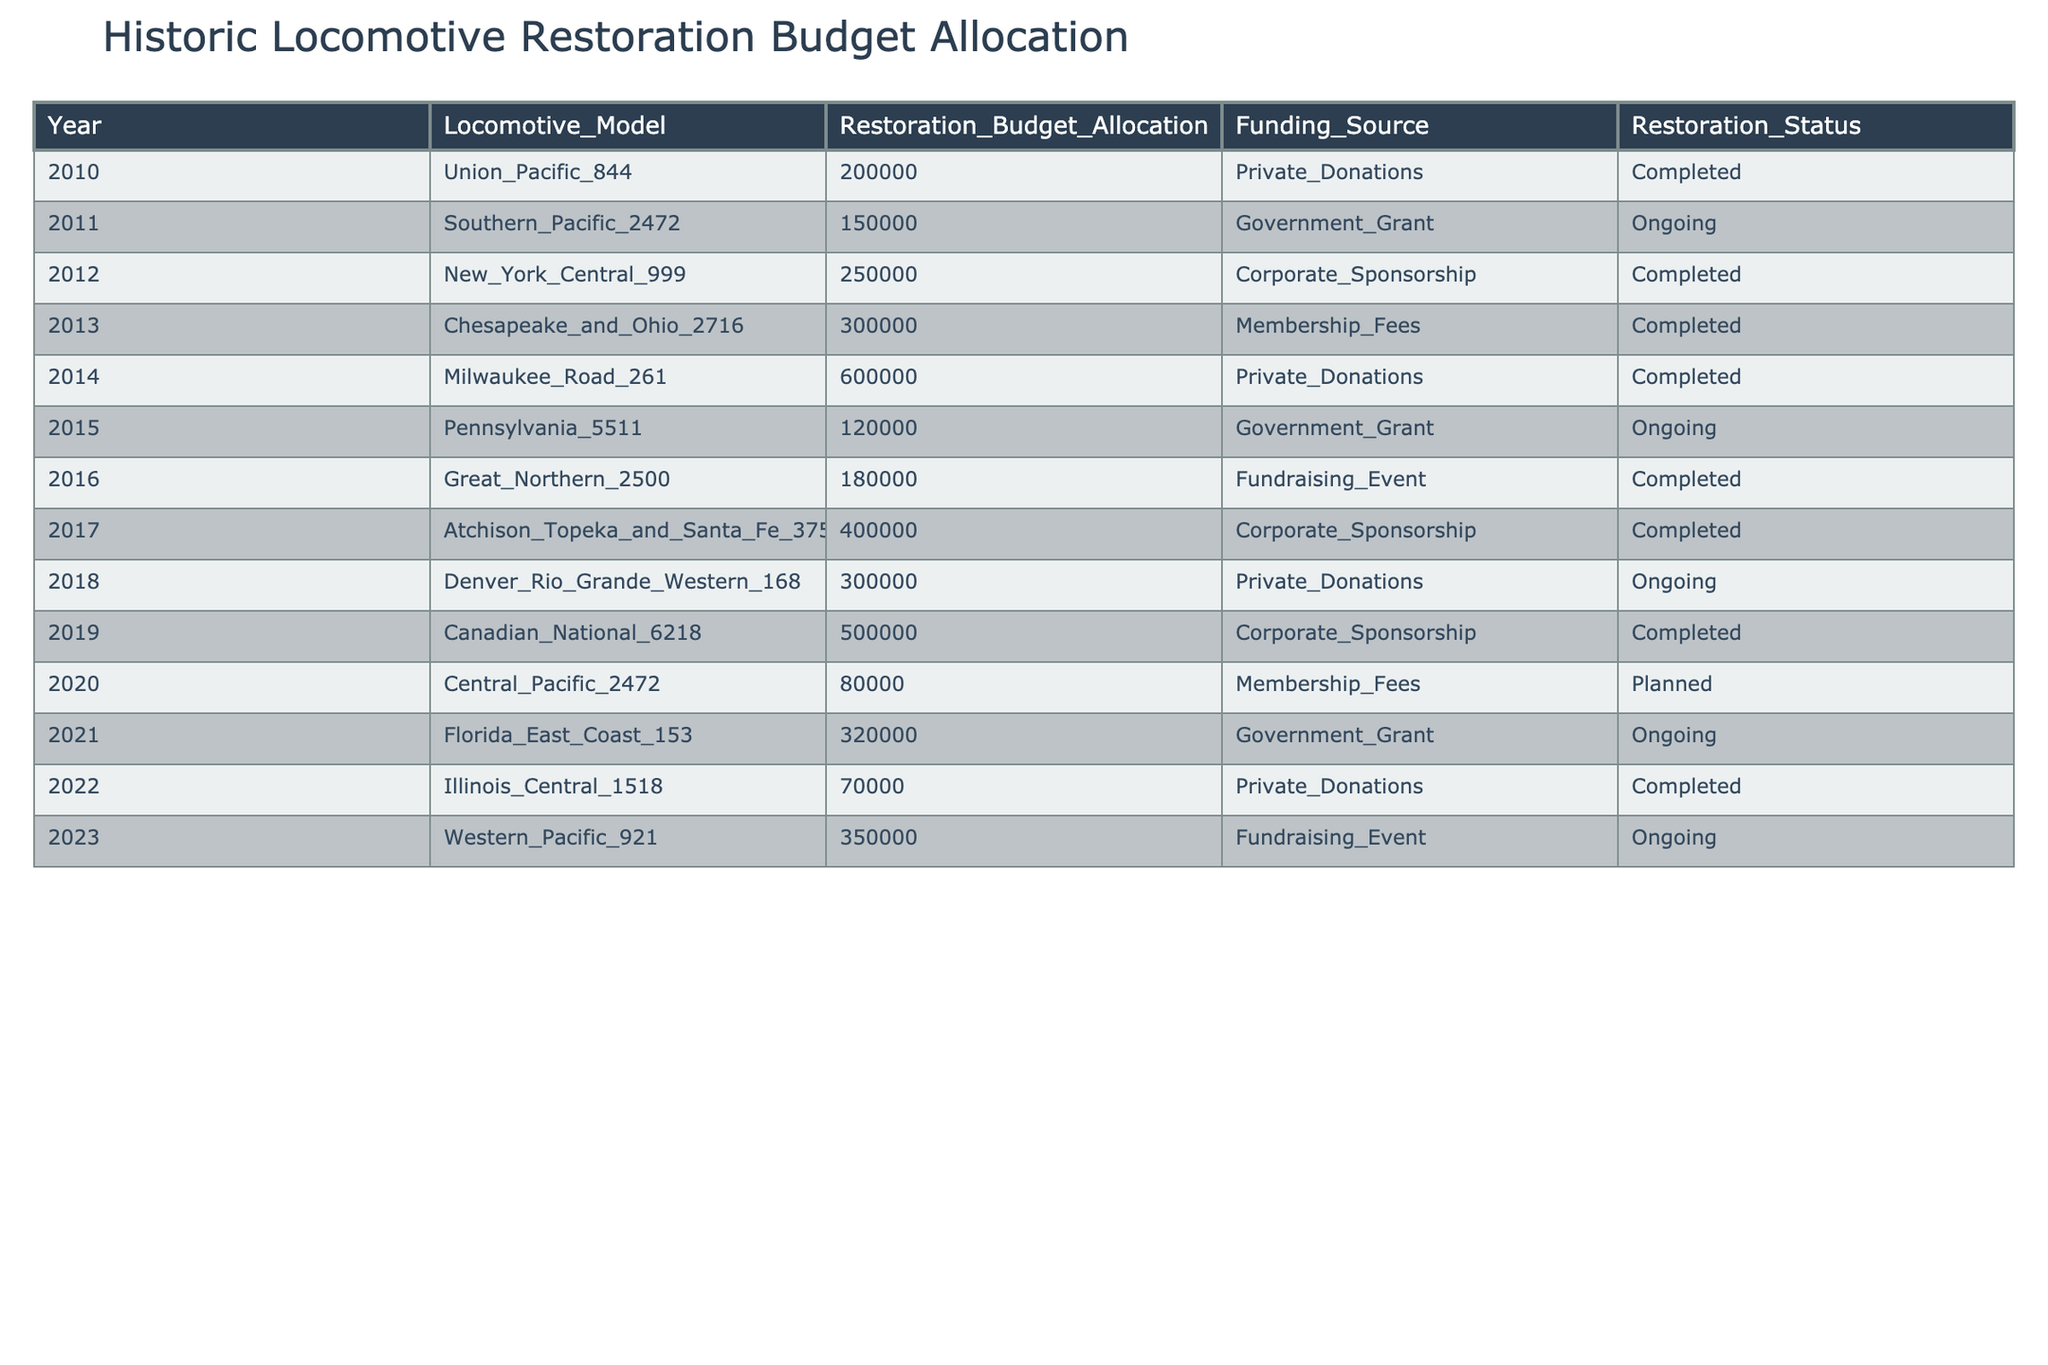What was the highest restoration budget allocation in the table? The table presents the restoration budget allocation for various locomotives. Scanning through the "Restoration_Budget_Allocation" column, the highest value is 600000 for the Milwaukee Road 261 in 2014.
Answer: 600000 How many locomotives had restoration funding from Government Grants? Looking at the "Funding_Source" column, I can count the occurrences where "Government_Grant" is mentioned. There are three such instances: in 2011 (Southern Pacific 2472), 2015 (Pennsylvania 5511), and 2021 (Florida East Coast 153).
Answer: 3 What is the restoration status of the locomotive with the lowest budget allocation? The lowest restoration budget allocation is 70000 for the Illinois Central 1518 in 2022 according to the table. Checking the "Restoration_Status" column, it indicates that this project is "Completed."
Answer: Completed How much was the total restoration budget allocation from 2010 to 2023? I will sum up all the values found in the "Restoration_Budget_Allocation" column from each year: 200000 + 150000 + 250000 + 300000 + 600000 + 120000 + 180000 + 400000 + 300000 + 500000 + 80000 + 320000 + 70000 + 350000. The total comes to 3250000.
Answer: 3250000 Which year had the highest restoration budget allocation from Corporate Sponsorship? I need to check the "Funding_Source" for "Corporate_Sponsorship" and identify the years associated with those budgets. The years with Corporate Sponsorship are 2012 (250000), 2017 (400000), and 2019 (500000). The highest allocation is in 2019 with 500000.
Answer: 2019 Is there any locomotion from 2020 that is marked as completed? Looking at the table, the 2020 entry for "Central Pacific 2472" shows a status of "Planned," indicating it's not completed. Therefore, there are no completed restorations from 2020.
Answer: No What proportion of locomotives in the table have an ongoing restoration status? Counting the total number of locomotives listed (14), then counting those with "Ongoing" status: this is 4 (Southern Pacific 2472, Pennsylvania 5511, Denver Rio Grande Western 168, and Western Pacific 921). Thus, the proportion is 4/14, which simplifies to approximately 0.29 or 29%.
Answer: 29% What was the average restoration budget allocation for completed projects? I need to sum the allocations for completed projects: 200000, 250000, 300000, 600000, 180000, 500000, 70000. This totals 2100000 for 7 completed projects, making the average 2100000/7, which equals 300000.
Answer: 300000 Which locomotive had the highest restoration budget allocation from Private Donations? Scanning through the table, "Milwaukee Road 261" in 2014 received 600000 as its funding source of Private Donations, which is the highest among the projects funded this way.
Answer: Milwaukee Road 261 Are there any years where all locomotives had a completed restoration status? I’ll look at the years listed and check their restoration statuses: 2010, 2012, 2013, 2014, 2016 are all completed. Since these are all completed, it shows there are years with entirely completed projects.
Answer: Yes 